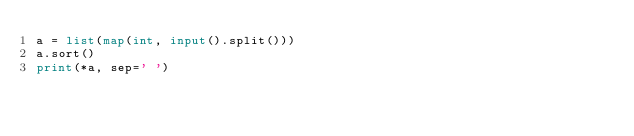<code> <loc_0><loc_0><loc_500><loc_500><_Python_>a = list(map(int, input().split()))
a.sort()
print(*a, sep=' ')
</code> 